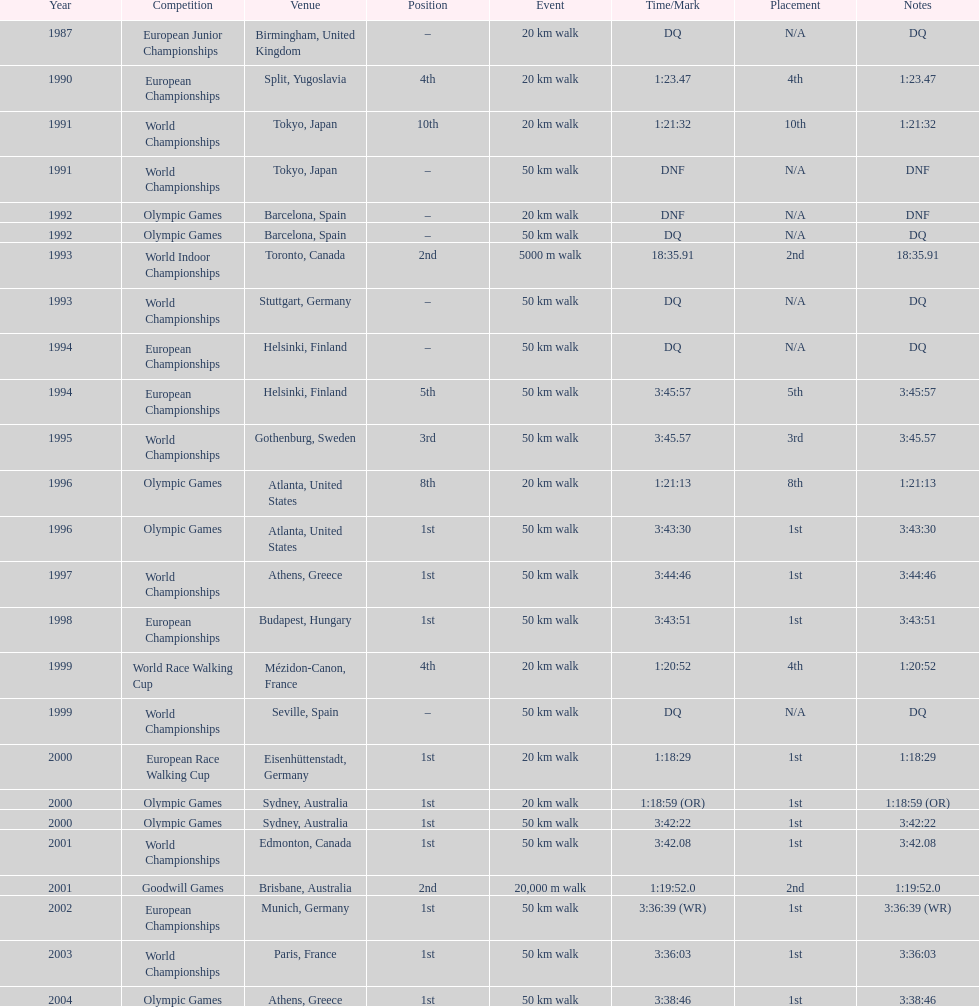In how many occurrences was korzeniowski disqualified from a tournament? 5. 